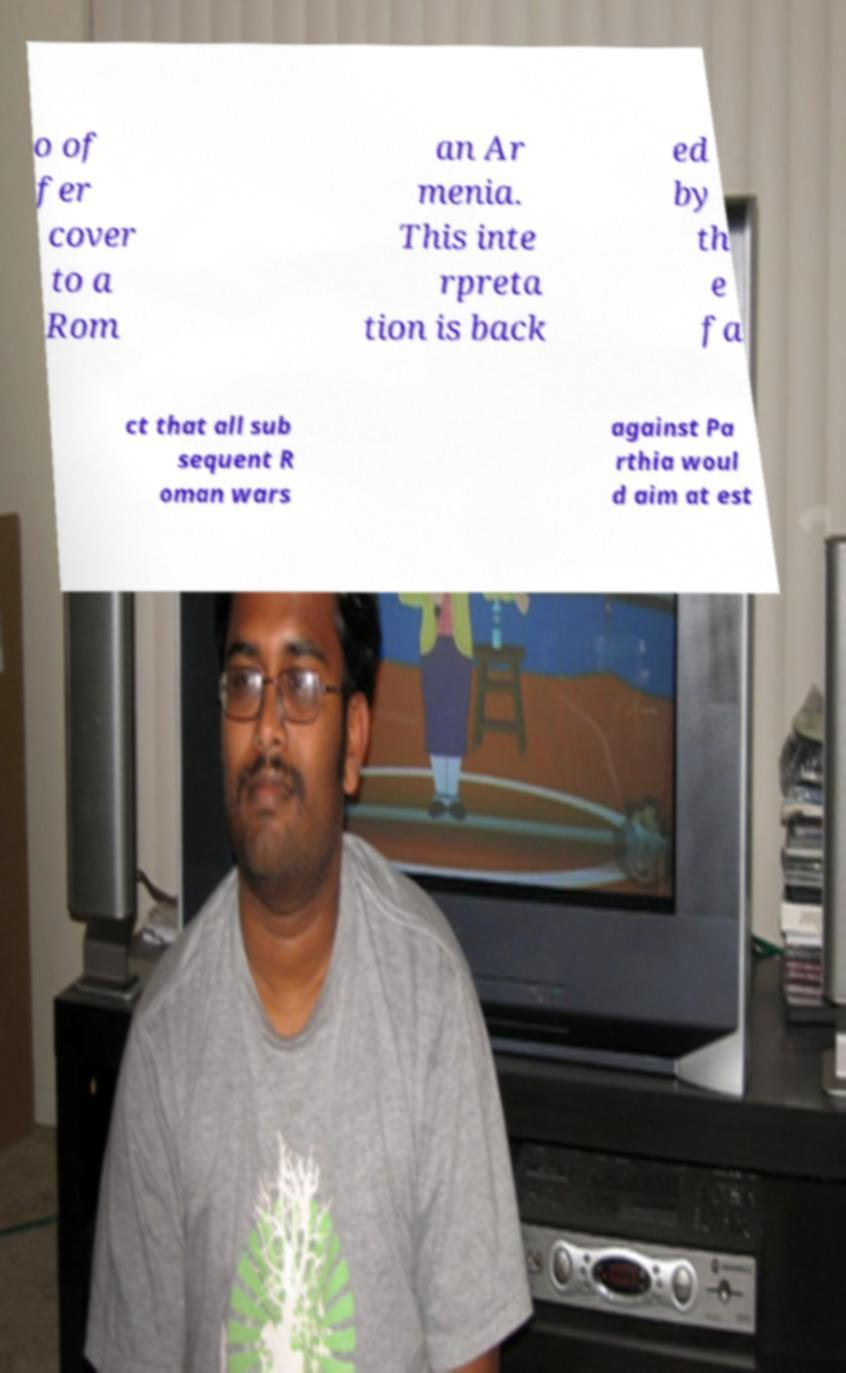Please identify and transcribe the text found in this image. o of fer cover to a Rom an Ar menia. This inte rpreta tion is back ed by th e fa ct that all sub sequent R oman wars against Pa rthia woul d aim at est 